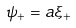Convert formula to latex. <formula><loc_0><loc_0><loc_500><loc_500>\psi _ { + } = a \xi _ { + }</formula> 